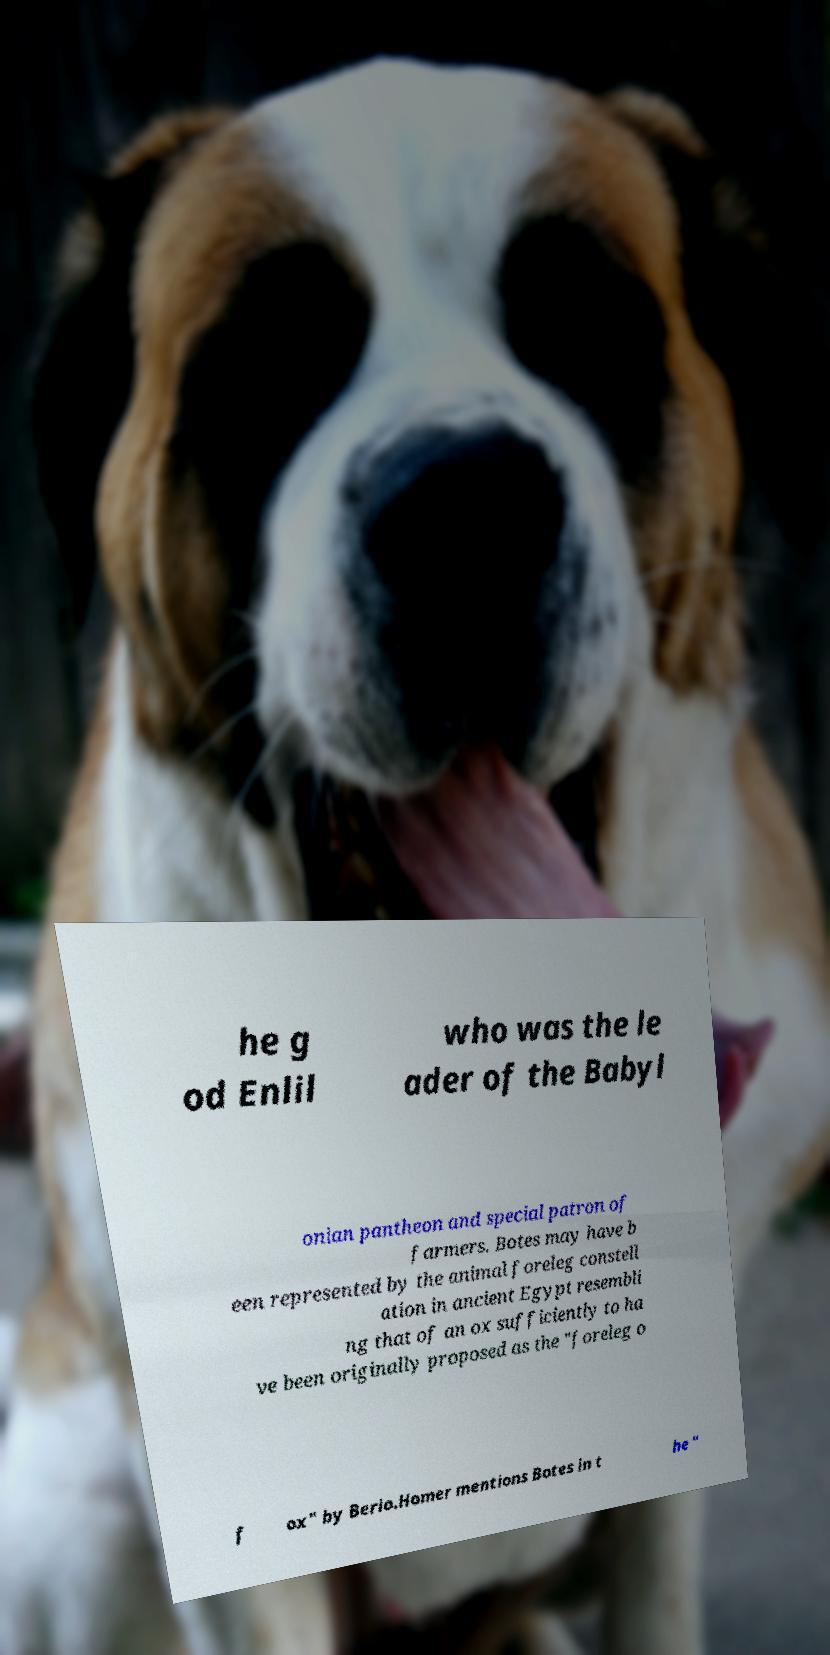Please identify and transcribe the text found in this image. he g od Enlil who was the le ader of the Babyl onian pantheon and special patron of farmers. Botes may have b een represented by the animal foreleg constell ation in ancient Egypt resembli ng that of an ox sufficiently to ha ve been originally proposed as the "foreleg o f ox" by Berio.Homer mentions Botes in t he " 